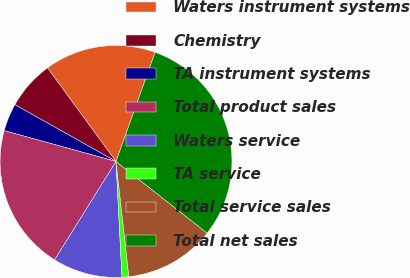Convert chart to OTSL. <chart><loc_0><loc_0><loc_500><loc_500><pie_chart><fcel>Waters instrument systems<fcel>Chemistry<fcel>TA instrument systems<fcel>Total product sales<fcel>Waters service<fcel>TA service<fcel>Total service sales<fcel>Total net sales<nl><fcel>15.54%<fcel>6.79%<fcel>3.87%<fcel>20.4%<fcel>9.7%<fcel>0.95%<fcel>12.62%<fcel>30.13%<nl></chart> 